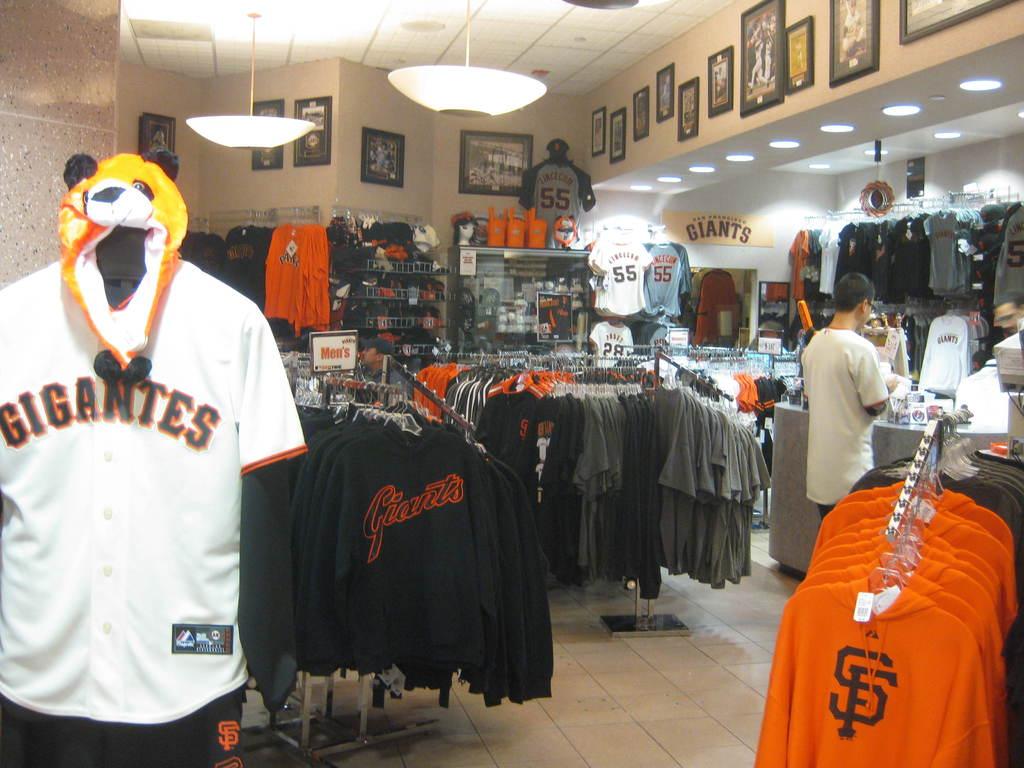What is the name of the team gear sold here?
Your answer should be compact. Gigantes. What player number are on the jerseys on the back wall?
Keep it short and to the point. 55. 